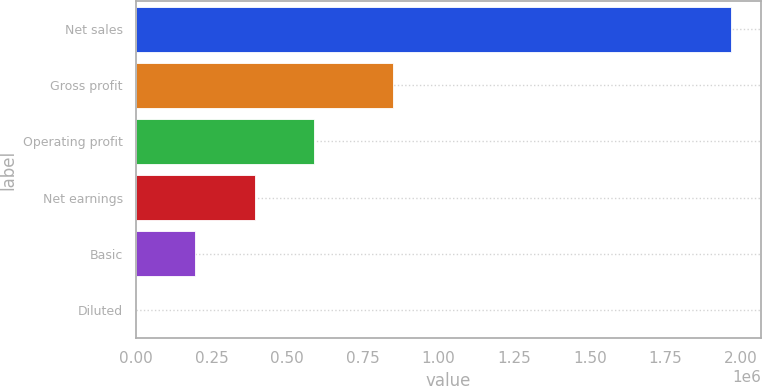<chart> <loc_0><loc_0><loc_500><loc_500><bar_chart><fcel>Net sales<fcel>Gross profit<fcel>Operating profit<fcel>Net earnings<fcel>Basic<fcel>Diluted<nl><fcel>1.96638e+06<fcel>847871<fcel>589913<fcel>393276<fcel>196638<fcel>0.7<nl></chart> 